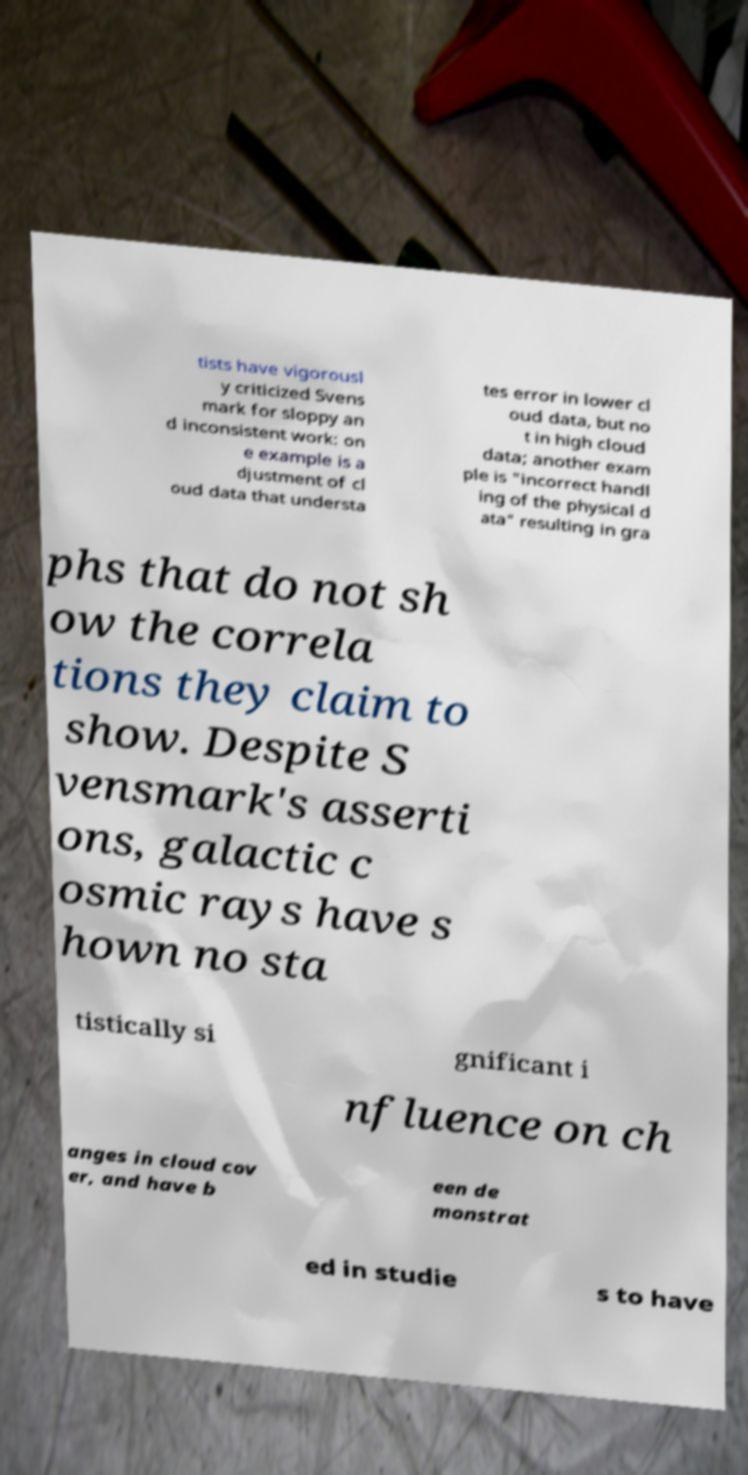Can you read and provide the text displayed in the image?This photo seems to have some interesting text. Can you extract and type it out for me? tists have vigorousl y criticized Svens mark for sloppy an d inconsistent work: on e example is a djustment of cl oud data that understa tes error in lower cl oud data, but no t in high cloud data; another exam ple is "incorrect handl ing of the physical d ata" resulting in gra phs that do not sh ow the correla tions they claim to show. Despite S vensmark's asserti ons, galactic c osmic rays have s hown no sta tistically si gnificant i nfluence on ch anges in cloud cov er, and have b een de monstrat ed in studie s to have 